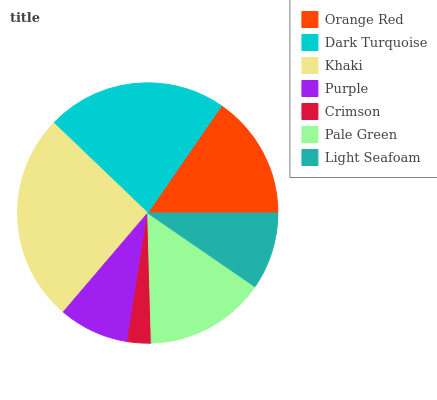Is Crimson the minimum?
Answer yes or no. Yes. Is Khaki the maximum?
Answer yes or no. Yes. Is Dark Turquoise the minimum?
Answer yes or no. No. Is Dark Turquoise the maximum?
Answer yes or no. No. Is Dark Turquoise greater than Orange Red?
Answer yes or no. Yes. Is Orange Red less than Dark Turquoise?
Answer yes or no. Yes. Is Orange Red greater than Dark Turquoise?
Answer yes or no. No. Is Dark Turquoise less than Orange Red?
Answer yes or no. No. Is Pale Green the high median?
Answer yes or no. Yes. Is Pale Green the low median?
Answer yes or no. Yes. Is Orange Red the high median?
Answer yes or no. No. Is Dark Turquoise the low median?
Answer yes or no. No. 